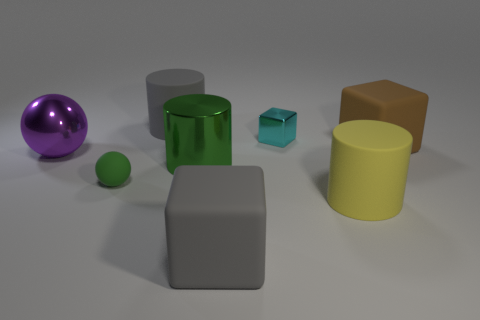Can you guess the possible size of these objects relative to each other? The yellow cylinder appears to be the largest object, followed by the brown cube and the gray matte cube, which seem to be similar in size but slightly smaller. The green glossy cylinder is smaller, roughly half the height of the yellow one. The purple metallic sphere and the blue rubber cube are smaller still, and the tiny green rubber sphere is the smallest visible object in the image. The sizes seem to be in proportion to one another, creating a varied but harmonious collection of forms. 